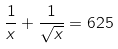<formula> <loc_0><loc_0><loc_500><loc_500>\frac { 1 } { x } + \frac { 1 } { \sqrt { x } } = 6 2 5</formula> 